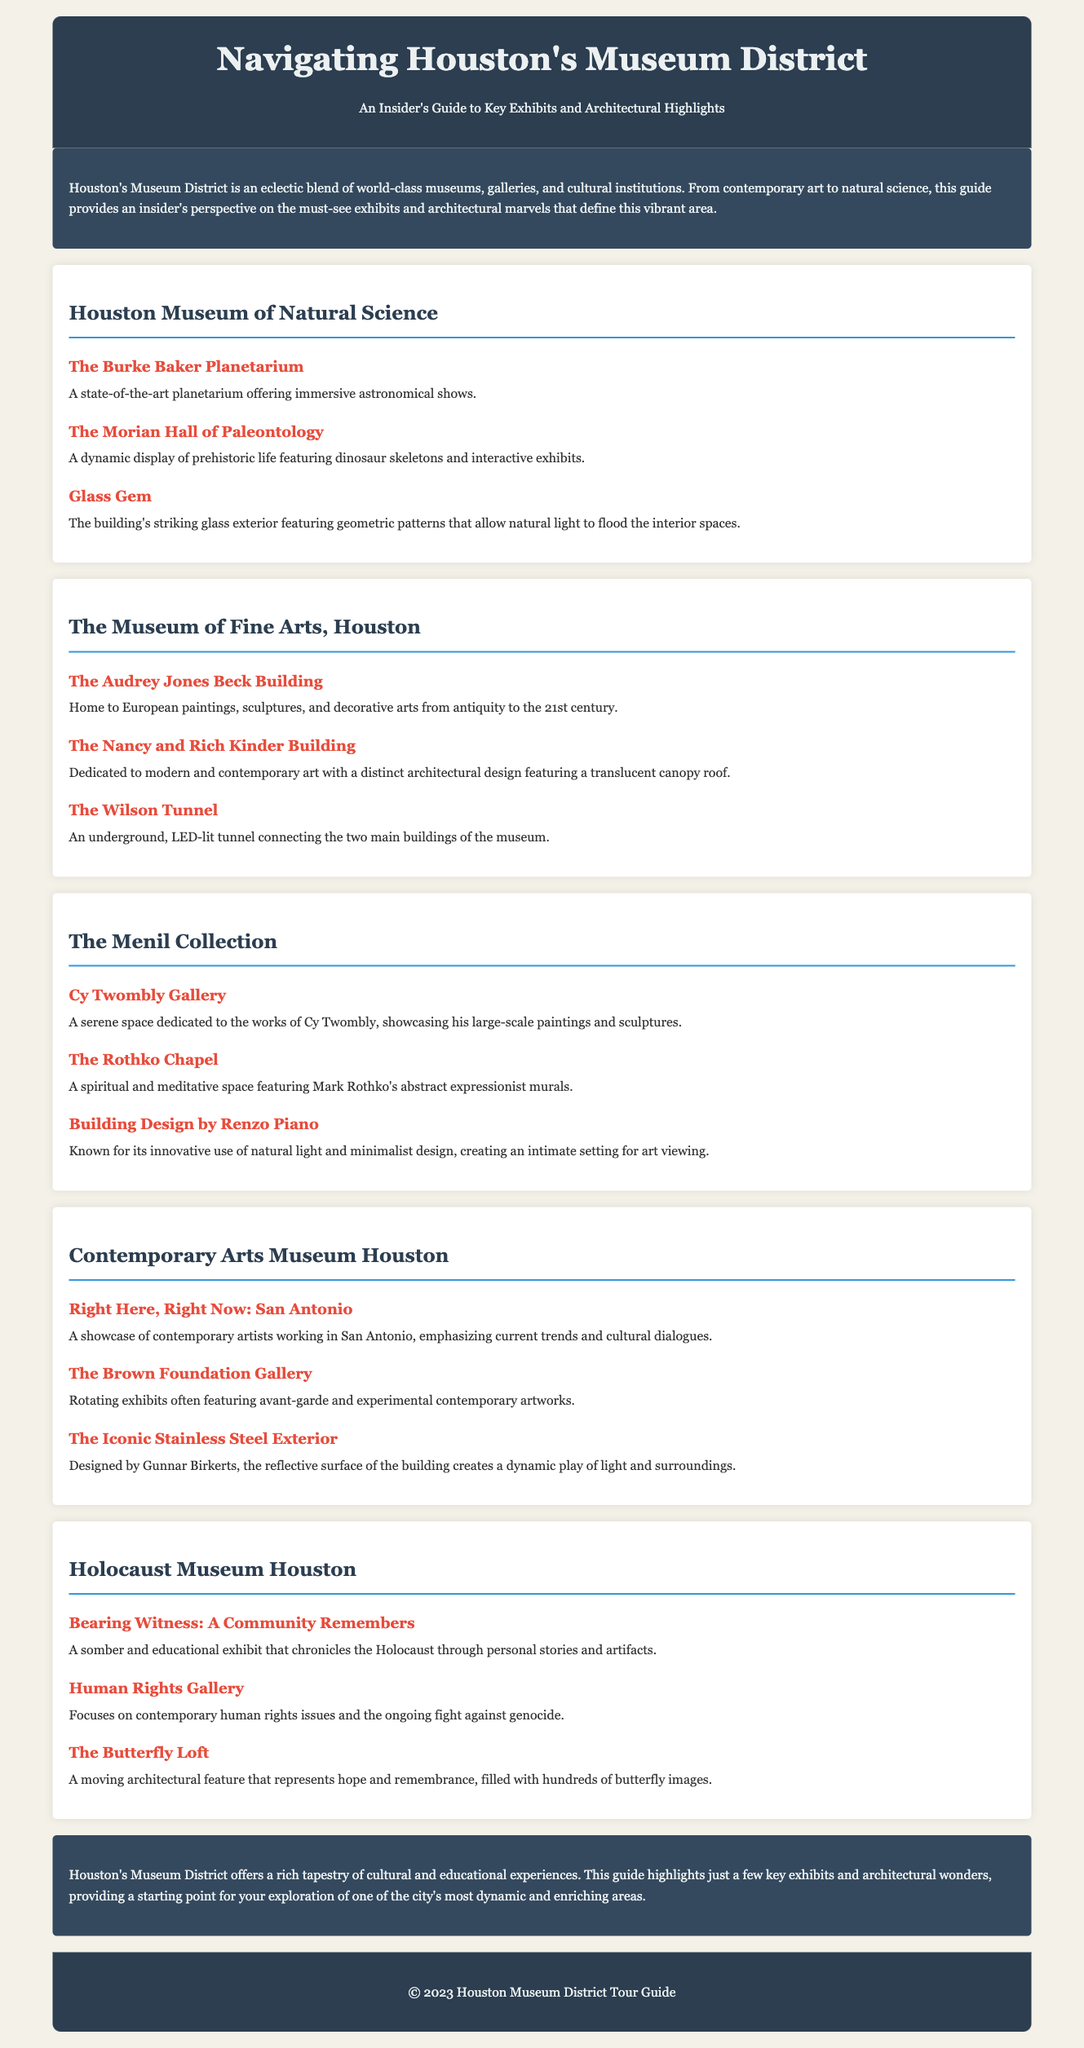what is the main theme of the document? The main theme of the document is an insider's guide to key exhibits and architectural highlights in Houston's Museum District.
Answer: Houston's Museum District how many museums are mentioned in the document? The document mentions five museums in the Museum District.
Answer: five what is the highlight of the Houston Museum of Natural Science? The highlight of the Houston Museum of Natural Science is the Glass Gem.
Answer: Glass Gem who designed the building for The Menil Collection? The building for The Menil Collection was designed by Renzo Piano.
Answer: Renzo Piano what type of exhibit is the "Bearing Witness: A Community Remembers"? The "Bearing Witness: A Community Remembers" exhibit is educational and chronicles the Holocaust.
Answer: somber and educational which museum features the "Right Here, Right Now: San Antonio" exhibit? The "Right Here, Right Now: San Antonio" exhibit is featured at the Contemporary Arts Museum Houston.
Answer: Contemporary Arts Museum Houston what architectural feature represents hope at the Holocaust Museum Houston? The architectural feature that represents hope at the Holocaust Museum Houston is The Butterfly Loft.
Answer: The Butterfly Loft which architectural highlight connects two main buildings at The Museum of Fine Arts, Houston? The Wilson Tunnel connects the two main buildings at The Museum of Fine Arts, Houston.
Answer: The Wilson Tunnel what does the Nancy and Rich Kinder Building focus on? The Nancy and Rich Kinder Building focuses on modern and contemporary art.
Answer: modern and contemporary art 